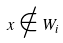<formula> <loc_0><loc_0><loc_500><loc_500>x \notin W _ { i }</formula> 